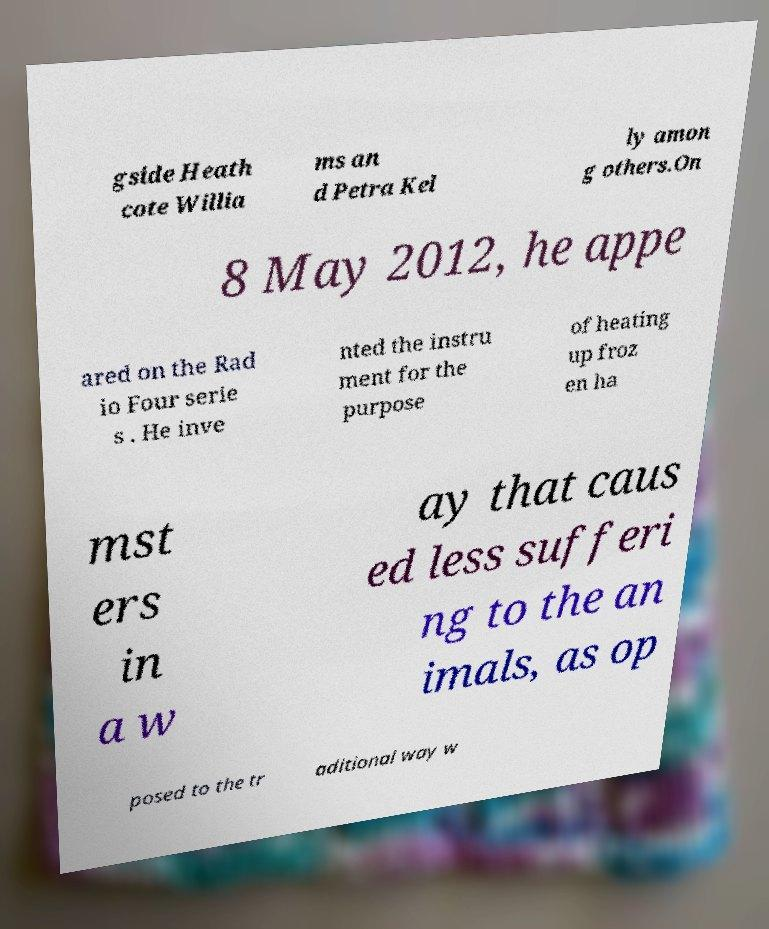Could you assist in decoding the text presented in this image and type it out clearly? gside Heath cote Willia ms an d Petra Kel ly amon g others.On 8 May 2012, he appe ared on the Rad io Four serie s . He inve nted the instru ment for the purpose of heating up froz en ha mst ers in a w ay that caus ed less sufferi ng to the an imals, as op posed to the tr aditional way w 